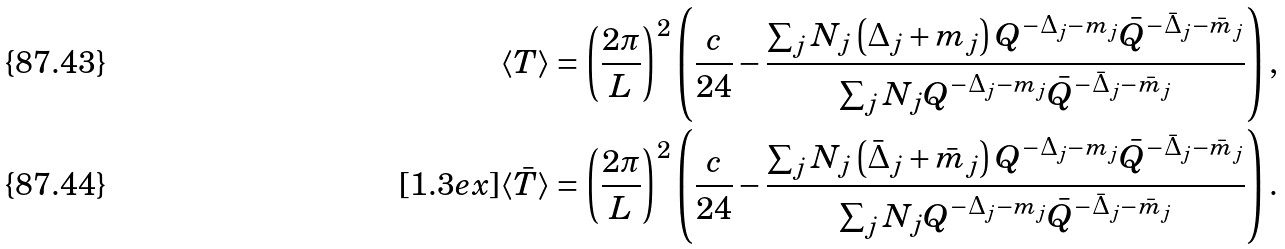Convert formula to latex. <formula><loc_0><loc_0><loc_500><loc_500>\langle T \rangle & = \left ( \frac { 2 \pi } { L } \right ) ^ { 2 } \left ( \frac { c } { 2 4 } - \frac { \sum _ { j } N _ { j } \left ( \Delta _ { j } + m _ { j } \right ) Q ^ { - \Delta _ { j } - m _ { j } } \bar { Q } ^ { - \bar { \Delta } _ { j } - \bar { m } _ { j } } } { \sum _ { j } N _ { j } Q ^ { - \Delta _ { j } - m _ { j } } \bar { Q } ^ { - \bar { \Delta } _ { j } - \bar { m } _ { j } } } \right ) , \\ [ 1 . 3 e x ] \langle \bar { T } \rangle & = \left ( \frac { 2 \pi } { L } \right ) ^ { 2 } \left ( \frac { c } { 2 4 } - \frac { \sum _ { j } N _ { j } \left ( \bar { \Delta } _ { j } + \bar { m } _ { j } \right ) Q ^ { - \Delta _ { j } - m _ { j } } \bar { Q } ^ { - \bar { \Delta } _ { j } - \bar { m } _ { j } } } { \sum _ { j } N _ { j } Q ^ { - \Delta _ { j } - m _ { j } } \bar { Q } ^ { - \bar { \Delta } _ { j } - \bar { m } _ { j } } } \right ) .</formula> 